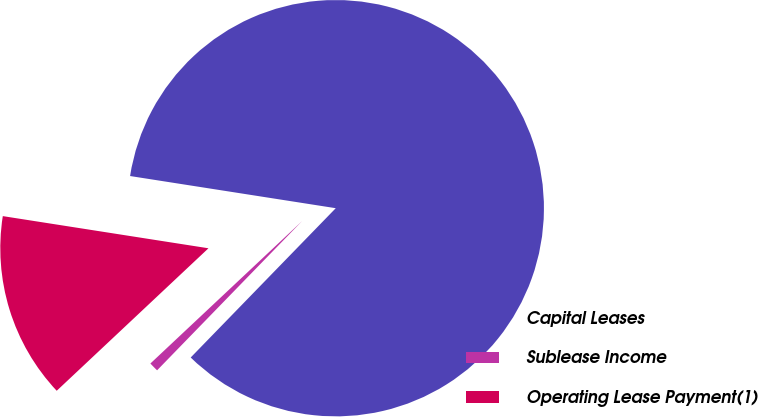Convert chart to OTSL. <chart><loc_0><loc_0><loc_500><loc_500><pie_chart><fcel>Capital Leases<fcel>Sublease Income<fcel>Operating Lease Payment(1)<nl><fcel>84.81%<fcel>0.73%<fcel>14.47%<nl></chart> 